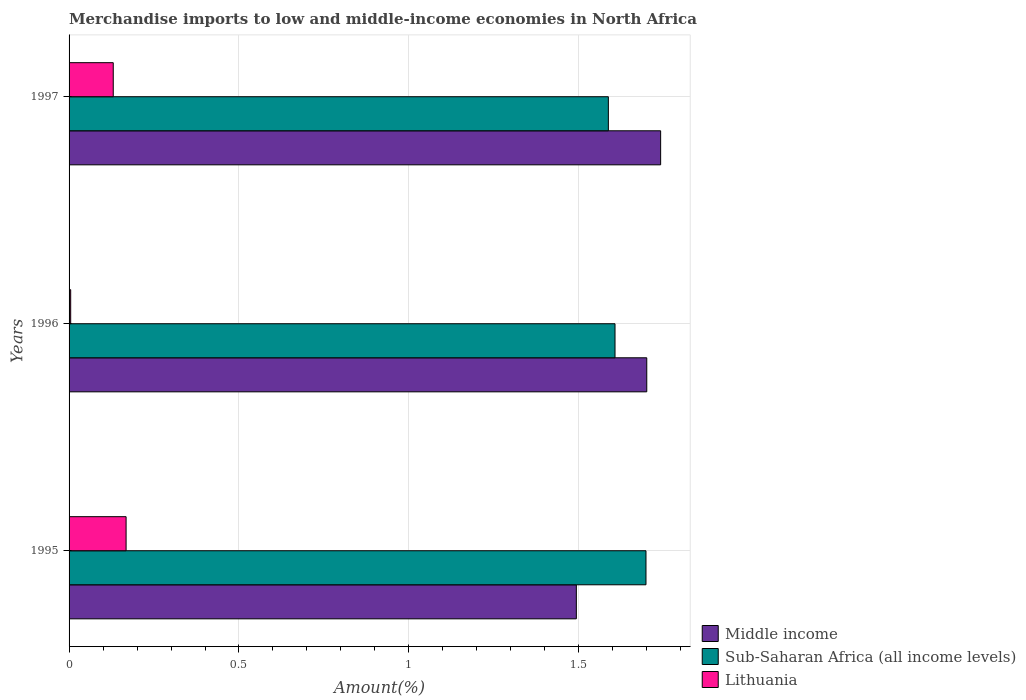How many different coloured bars are there?
Keep it short and to the point. 3. Are the number of bars per tick equal to the number of legend labels?
Your answer should be very brief. Yes. Are the number of bars on each tick of the Y-axis equal?
Make the answer very short. Yes. How many bars are there on the 2nd tick from the bottom?
Your answer should be compact. 3. What is the label of the 2nd group of bars from the top?
Your response must be concise. 1996. What is the percentage of amount earned from merchandise imports in Middle income in 1997?
Make the answer very short. 1.74. Across all years, what is the maximum percentage of amount earned from merchandise imports in Middle income?
Give a very brief answer. 1.74. Across all years, what is the minimum percentage of amount earned from merchandise imports in Sub-Saharan Africa (all income levels)?
Offer a very short reply. 1.59. In which year was the percentage of amount earned from merchandise imports in Middle income maximum?
Offer a terse response. 1997. What is the total percentage of amount earned from merchandise imports in Sub-Saharan Africa (all income levels) in the graph?
Ensure brevity in your answer.  4.89. What is the difference between the percentage of amount earned from merchandise imports in Middle income in 1995 and that in 1996?
Provide a short and direct response. -0.21. What is the difference between the percentage of amount earned from merchandise imports in Middle income in 1996 and the percentage of amount earned from merchandise imports in Lithuania in 1997?
Your response must be concise. 1.57. What is the average percentage of amount earned from merchandise imports in Lithuania per year?
Your response must be concise. 0.1. In the year 1996, what is the difference between the percentage of amount earned from merchandise imports in Lithuania and percentage of amount earned from merchandise imports in Sub-Saharan Africa (all income levels)?
Give a very brief answer. -1.6. In how many years, is the percentage of amount earned from merchandise imports in Middle income greater than 0.2 %?
Your answer should be compact. 3. What is the ratio of the percentage of amount earned from merchandise imports in Middle income in 1995 to that in 1996?
Offer a terse response. 0.88. Is the percentage of amount earned from merchandise imports in Middle income in 1996 less than that in 1997?
Ensure brevity in your answer.  Yes. Is the difference between the percentage of amount earned from merchandise imports in Lithuania in 1996 and 1997 greater than the difference between the percentage of amount earned from merchandise imports in Sub-Saharan Africa (all income levels) in 1996 and 1997?
Give a very brief answer. No. What is the difference between the highest and the second highest percentage of amount earned from merchandise imports in Sub-Saharan Africa (all income levels)?
Provide a succinct answer. 0.09. What is the difference between the highest and the lowest percentage of amount earned from merchandise imports in Sub-Saharan Africa (all income levels)?
Make the answer very short. 0.11. In how many years, is the percentage of amount earned from merchandise imports in Lithuania greater than the average percentage of amount earned from merchandise imports in Lithuania taken over all years?
Your answer should be compact. 2. Is the sum of the percentage of amount earned from merchandise imports in Middle income in 1996 and 1997 greater than the maximum percentage of amount earned from merchandise imports in Sub-Saharan Africa (all income levels) across all years?
Provide a short and direct response. Yes. What does the 1st bar from the top in 1996 represents?
Your answer should be compact. Lithuania. What does the 2nd bar from the bottom in 1997 represents?
Make the answer very short. Sub-Saharan Africa (all income levels). What is the difference between two consecutive major ticks on the X-axis?
Provide a succinct answer. 0.5. Are the values on the major ticks of X-axis written in scientific E-notation?
Ensure brevity in your answer.  No. Where does the legend appear in the graph?
Your answer should be compact. Bottom right. How many legend labels are there?
Your answer should be compact. 3. How are the legend labels stacked?
Offer a terse response. Vertical. What is the title of the graph?
Offer a terse response. Merchandise imports to low and middle-income economies in North Africa. What is the label or title of the X-axis?
Keep it short and to the point. Amount(%). What is the label or title of the Y-axis?
Provide a succinct answer. Years. What is the Amount(%) in Middle income in 1995?
Ensure brevity in your answer.  1.49. What is the Amount(%) of Sub-Saharan Africa (all income levels) in 1995?
Keep it short and to the point. 1.7. What is the Amount(%) of Lithuania in 1995?
Give a very brief answer. 0.17. What is the Amount(%) in Middle income in 1996?
Keep it short and to the point. 1.7. What is the Amount(%) in Sub-Saharan Africa (all income levels) in 1996?
Provide a succinct answer. 1.61. What is the Amount(%) of Lithuania in 1996?
Your response must be concise. 0. What is the Amount(%) in Middle income in 1997?
Offer a terse response. 1.74. What is the Amount(%) of Sub-Saharan Africa (all income levels) in 1997?
Your answer should be very brief. 1.59. What is the Amount(%) in Lithuania in 1997?
Give a very brief answer. 0.13. Across all years, what is the maximum Amount(%) in Middle income?
Offer a very short reply. 1.74. Across all years, what is the maximum Amount(%) of Sub-Saharan Africa (all income levels)?
Your answer should be compact. 1.7. Across all years, what is the maximum Amount(%) of Lithuania?
Ensure brevity in your answer.  0.17. Across all years, what is the minimum Amount(%) in Middle income?
Keep it short and to the point. 1.49. Across all years, what is the minimum Amount(%) of Sub-Saharan Africa (all income levels)?
Make the answer very short. 1.59. Across all years, what is the minimum Amount(%) of Lithuania?
Provide a short and direct response. 0. What is the total Amount(%) of Middle income in the graph?
Keep it short and to the point. 4.93. What is the total Amount(%) of Sub-Saharan Africa (all income levels) in the graph?
Give a very brief answer. 4.89. What is the total Amount(%) in Lithuania in the graph?
Offer a terse response. 0.3. What is the difference between the Amount(%) of Middle income in 1995 and that in 1996?
Your answer should be compact. -0.21. What is the difference between the Amount(%) in Sub-Saharan Africa (all income levels) in 1995 and that in 1996?
Keep it short and to the point. 0.09. What is the difference between the Amount(%) in Lithuania in 1995 and that in 1996?
Provide a succinct answer. 0.16. What is the difference between the Amount(%) in Middle income in 1995 and that in 1997?
Your response must be concise. -0.25. What is the difference between the Amount(%) in Sub-Saharan Africa (all income levels) in 1995 and that in 1997?
Give a very brief answer. 0.11. What is the difference between the Amount(%) in Lithuania in 1995 and that in 1997?
Keep it short and to the point. 0.04. What is the difference between the Amount(%) of Middle income in 1996 and that in 1997?
Your response must be concise. -0.04. What is the difference between the Amount(%) of Sub-Saharan Africa (all income levels) in 1996 and that in 1997?
Make the answer very short. 0.02. What is the difference between the Amount(%) of Lithuania in 1996 and that in 1997?
Ensure brevity in your answer.  -0.13. What is the difference between the Amount(%) of Middle income in 1995 and the Amount(%) of Sub-Saharan Africa (all income levels) in 1996?
Give a very brief answer. -0.11. What is the difference between the Amount(%) in Middle income in 1995 and the Amount(%) in Lithuania in 1996?
Your answer should be compact. 1.49. What is the difference between the Amount(%) of Sub-Saharan Africa (all income levels) in 1995 and the Amount(%) of Lithuania in 1996?
Your response must be concise. 1.69. What is the difference between the Amount(%) in Middle income in 1995 and the Amount(%) in Sub-Saharan Africa (all income levels) in 1997?
Provide a succinct answer. -0.09. What is the difference between the Amount(%) of Middle income in 1995 and the Amount(%) of Lithuania in 1997?
Offer a terse response. 1.36. What is the difference between the Amount(%) in Sub-Saharan Africa (all income levels) in 1995 and the Amount(%) in Lithuania in 1997?
Offer a very short reply. 1.57. What is the difference between the Amount(%) in Middle income in 1996 and the Amount(%) in Sub-Saharan Africa (all income levels) in 1997?
Offer a very short reply. 0.11. What is the difference between the Amount(%) of Middle income in 1996 and the Amount(%) of Lithuania in 1997?
Keep it short and to the point. 1.57. What is the difference between the Amount(%) in Sub-Saharan Africa (all income levels) in 1996 and the Amount(%) in Lithuania in 1997?
Ensure brevity in your answer.  1.48. What is the average Amount(%) of Middle income per year?
Offer a very short reply. 1.64. What is the average Amount(%) in Sub-Saharan Africa (all income levels) per year?
Offer a very short reply. 1.63. What is the average Amount(%) of Lithuania per year?
Make the answer very short. 0.1. In the year 1995, what is the difference between the Amount(%) in Middle income and Amount(%) in Sub-Saharan Africa (all income levels)?
Offer a terse response. -0.2. In the year 1995, what is the difference between the Amount(%) of Middle income and Amount(%) of Lithuania?
Offer a terse response. 1.32. In the year 1995, what is the difference between the Amount(%) of Sub-Saharan Africa (all income levels) and Amount(%) of Lithuania?
Keep it short and to the point. 1.53. In the year 1996, what is the difference between the Amount(%) of Middle income and Amount(%) of Sub-Saharan Africa (all income levels)?
Offer a terse response. 0.09. In the year 1996, what is the difference between the Amount(%) in Middle income and Amount(%) in Lithuania?
Ensure brevity in your answer.  1.7. In the year 1996, what is the difference between the Amount(%) of Sub-Saharan Africa (all income levels) and Amount(%) of Lithuania?
Offer a terse response. 1.6. In the year 1997, what is the difference between the Amount(%) of Middle income and Amount(%) of Sub-Saharan Africa (all income levels)?
Your answer should be compact. 0.15. In the year 1997, what is the difference between the Amount(%) in Middle income and Amount(%) in Lithuania?
Your answer should be compact. 1.61. In the year 1997, what is the difference between the Amount(%) of Sub-Saharan Africa (all income levels) and Amount(%) of Lithuania?
Your response must be concise. 1.46. What is the ratio of the Amount(%) of Middle income in 1995 to that in 1996?
Offer a very short reply. 0.88. What is the ratio of the Amount(%) in Sub-Saharan Africa (all income levels) in 1995 to that in 1996?
Provide a short and direct response. 1.06. What is the ratio of the Amount(%) in Lithuania in 1995 to that in 1996?
Provide a short and direct response. 35.26. What is the ratio of the Amount(%) of Middle income in 1995 to that in 1997?
Ensure brevity in your answer.  0.86. What is the ratio of the Amount(%) of Sub-Saharan Africa (all income levels) in 1995 to that in 1997?
Your answer should be very brief. 1.07. What is the ratio of the Amount(%) of Lithuania in 1995 to that in 1997?
Keep it short and to the point. 1.29. What is the ratio of the Amount(%) in Middle income in 1996 to that in 1997?
Your answer should be compact. 0.98. What is the ratio of the Amount(%) of Sub-Saharan Africa (all income levels) in 1996 to that in 1997?
Make the answer very short. 1.01. What is the ratio of the Amount(%) in Lithuania in 1996 to that in 1997?
Offer a terse response. 0.04. What is the difference between the highest and the second highest Amount(%) in Middle income?
Your answer should be very brief. 0.04. What is the difference between the highest and the second highest Amount(%) in Sub-Saharan Africa (all income levels)?
Provide a short and direct response. 0.09. What is the difference between the highest and the second highest Amount(%) in Lithuania?
Make the answer very short. 0.04. What is the difference between the highest and the lowest Amount(%) of Middle income?
Ensure brevity in your answer.  0.25. What is the difference between the highest and the lowest Amount(%) of Sub-Saharan Africa (all income levels)?
Give a very brief answer. 0.11. What is the difference between the highest and the lowest Amount(%) of Lithuania?
Your response must be concise. 0.16. 